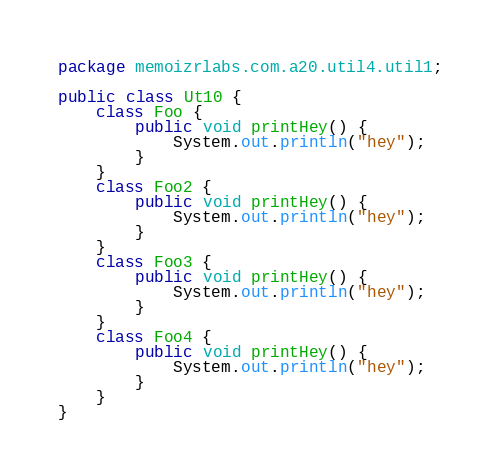Convert code to text. <code><loc_0><loc_0><loc_500><loc_500><_Java_>package memoizrlabs.com.a20.util4.util1;

public class Ut10 {
    class Foo {
        public void printHey() {
            System.out.println("hey");
        }
    }
    class Foo2 {
        public void printHey() {
            System.out.println("hey");
        }
    }
    class Foo3 {
        public void printHey() {
            System.out.println("hey");
        }
    }
    class Foo4 {
        public void printHey() {
            System.out.println("hey");
        }
    }
}
</code> 